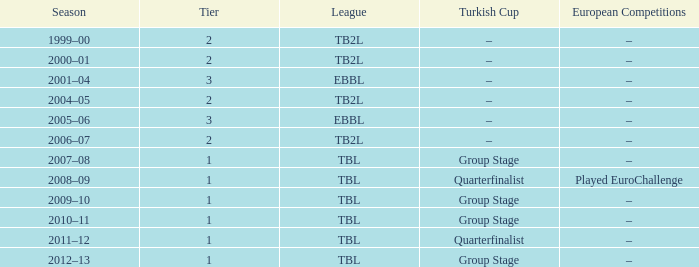Season of 2012–13 is what league? TBL. 